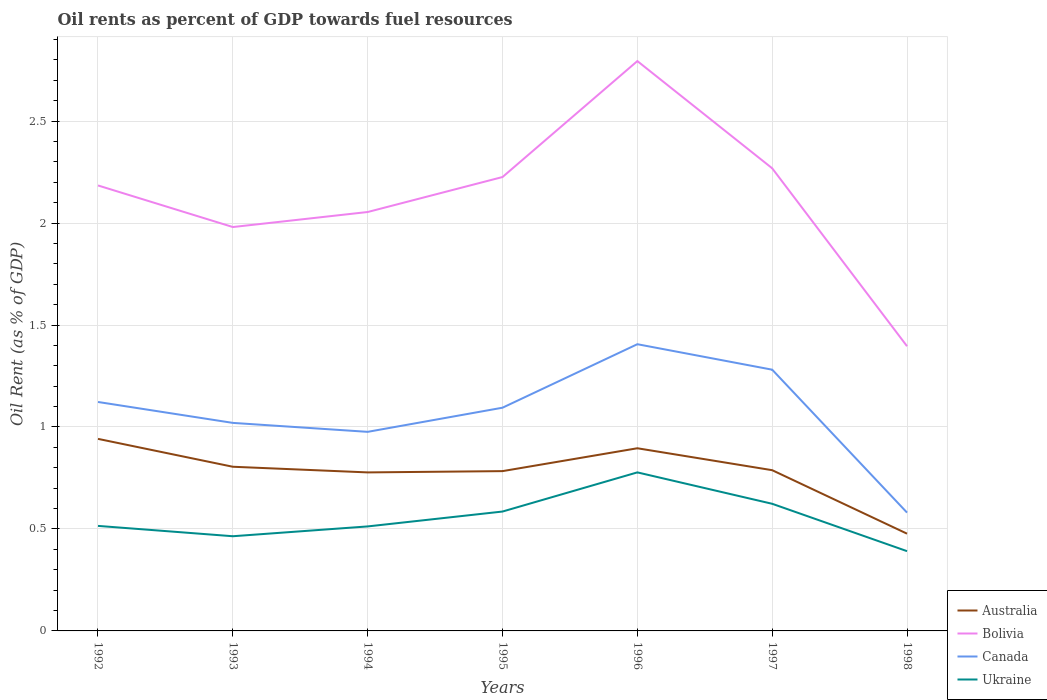Does the line corresponding to Ukraine intersect with the line corresponding to Bolivia?
Provide a succinct answer. No. Across all years, what is the maximum oil rent in Canada?
Offer a very short reply. 0.58. In which year was the oil rent in Australia maximum?
Your response must be concise. 1998. What is the total oil rent in Australia in the graph?
Offer a very short reply. 0.46. What is the difference between the highest and the second highest oil rent in Ukraine?
Give a very brief answer. 0.39. How many lines are there?
Ensure brevity in your answer.  4. What is the difference between two consecutive major ticks on the Y-axis?
Give a very brief answer. 0.5. Does the graph contain grids?
Offer a very short reply. Yes. Where does the legend appear in the graph?
Offer a very short reply. Bottom right. How are the legend labels stacked?
Offer a very short reply. Vertical. What is the title of the graph?
Provide a succinct answer. Oil rents as percent of GDP towards fuel resources. Does "Cayman Islands" appear as one of the legend labels in the graph?
Make the answer very short. No. What is the label or title of the Y-axis?
Ensure brevity in your answer.  Oil Rent (as % of GDP). What is the Oil Rent (as % of GDP) of Australia in 1992?
Provide a short and direct response. 0.94. What is the Oil Rent (as % of GDP) in Bolivia in 1992?
Your answer should be compact. 2.18. What is the Oil Rent (as % of GDP) of Canada in 1992?
Offer a very short reply. 1.12. What is the Oil Rent (as % of GDP) in Ukraine in 1992?
Give a very brief answer. 0.52. What is the Oil Rent (as % of GDP) in Australia in 1993?
Offer a very short reply. 0.81. What is the Oil Rent (as % of GDP) of Bolivia in 1993?
Keep it short and to the point. 1.98. What is the Oil Rent (as % of GDP) of Canada in 1993?
Your answer should be compact. 1.02. What is the Oil Rent (as % of GDP) of Ukraine in 1993?
Offer a very short reply. 0.46. What is the Oil Rent (as % of GDP) of Australia in 1994?
Offer a very short reply. 0.78. What is the Oil Rent (as % of GDP) of Bolivia in 1994?
Your answer should be compact. 2.05. What is the Oil Rent (as % of GDP) of Canada in 1994?
Keep it short and to the point. 0.98. What is the Oil Rent (as % of GDP) in Ukraine in 1994?
Make the answer very short. 0.51. What is the Oil Rent (as % of GDP) of Australia in 1995?
Provide a short and direct response. 0.78. What is the Oil Rent (as % of GDP) of Bolivia in 1995?
Keep it short and to the point. 2.23. What is the Oil Rent (as % of GDP) in Canada in 1995?
Ensure brevity in your answer.  1.09. What is the Oil Rent (as % of GDP) of Ukraine in 1995?
Offer a terse response. 0.59. What is the Oil Rent (as % of GDP) of Australia in 1996?
Give a very brief answer. 0.9. What is the Oil Rent (as % of GDP) in Bolivia in 1996?
Your answer should be very brief. 2.79. What is the Oil Rent (as % of GDP) of Canada in 1996?
Keep it short and to the point. 1.41. What is the Oil Rent (as % of GDP) of Ukraine in 1996?
Your answer should be very brief. 0.78. What is the Oil Rent (as % of GDP) in Australia in 1997?
Your response must be concise. 0.79. What is the Oil Rent (as % of GDP) of Bolivia in 1997?
Offer a terse response. 2.27. What is the Oil Rent (as % of GDP) in Canada in 1997?
Your response must be concise. 1.28. What is the Oil Rent (as % of GDP) of Ukraine in 1997?
Ensure brevity in your answer.  0.62. What is the Oil Rent (as % of GDP) of Australia in 1998?
Give a very brief answer. 0.48. What is the Oil Rent (as % of GDP) in Bolivia in 1998?
Provide a succinct answer. 1.4. What is the Oil Rent (as % of GDP) in Canada in 1998?
Your answer should be very brief. 0.58. What is the Oil Rent (as % of GDP) of Ukraine in 1998?
Make the answer very short. 0.39. Across all years, what is the maximum Oil Rent (as % of GDP) in Australia?
Provide a short and direct response. 0.94. Across all years, what is the maximum Oil Rent (as % of GDP) of Bolivia?
Your answer should be compact. 2.79. Across all years, what is the maximum Oil Rent (as % of GDP) of Canada?
Ensure brevity in your answer.  1.41. Across all years, what is the maximum Oil Rent (as % of GDP) in Ukraine?
Your answer should be compact. 0.78. Across all years, what is the minimum Oil Rent (as % of GDP) of Australia?
Offer a very short reply. 0.48. Across all years, what is the minimum Oil Rent (as % of GDP) in Bolivia?
Ensure brevity in your answer.  1.4. Across all years, what is the minimum Oil Rent (as % of GDP) of Canada?
Give a very brief answer. 0.58. Across all years, what is the minimum Oil Rent (as % of GDP) of Ukraine?
Your answer should be compact. 0.39. What is the total Oil Rent (as % of GDP) in Australia in the graph?
Your response must be concise. 5.47. What is the total Oil Rent (as % of GDP) of Bolivia in the graph?
Provide a succinct answer. 14.9. What is the total Oil Rent (as % of GDP) in Canada in the graph?
Provide a short and direct response. 7.48. What is the total Oil Rent (as % of GDP) in Ukraine in the graph?
Provide a succinct answer. 3.87. What is the difference between the Oil Rent (as % of GDP) in Australia in 1992 and that in 1993?
Offer a very short reply. 0.14. What is the difference between the Oil Rent (as % of GDP) in Bolivia in 1992 and that in 1993?
Your answer should be compact. 0.2. What is the difference between the Oil Rent (as % of GDP) in Canada in 1992 and that in 1993?
Provide a short and direct response. 0.1. What is the difference between the Oil Rent (as % of GDP) in Ukraine in 1992 and that in 1993?
Give a very brief answer. 0.05. What is the difference between the Oil Rent (as % of GDP) in Australia in 1992 and that in 1994?
Provide a short and direct response. 0.16. What is the difference between the Oil Rent (as % of GDP) of Bolivia in 1992 and that in 1994?
Provide a short and direct response. 0.13. What is the difference between the Oil Rent (as % of GDP) in Canada in 1992 and that in 1994?
Provide a succinct answer. 0.15. What is the difference between the Oil Rent (as % of GDP) of Ukraine in 1992 and that in 1994?
Provide a succinct answer. 0. What is the difference between the Oil Rent (as % of GDP) in Australia in 1992 and that in 1995?
Provide a short and direct response. 0.16. What is the difference between the Oil Rent (as % of GDP) in Bolivia in 1992 and that in 1995?
Your response must be concise. -0.04. What is the difference between the Oil Rent (as % of GDP) in Canada in 1992 and that in 1995?
Ensure brevity in your answer.  0.03. What is the difference between the Oil Rent (as % of GDP) of Ukraine in 1992 and that in 1995?
Give a very brief answer. -0.07. What is the difference between the Oil Rent (as % of GDP) in Australia in 1992 and that in 1996?
Keep it short and to the point. 0.05. What is the difference between the Oil Rent (as % of GDP) in Bolivia in 1992 and that in 1996?
Your response must be concise. -0.61. What is the difference between the Oil Rent (as % of GDP) in Canada in 1992 and that in 1996?
Offer a terse response. -0.28. What is the difference between the Oil Rent (as % of GDP) in Ukraine in 1992 and that in 1996?
Ensure brevity in your answer.  -0.26. What is the difference between the Oil Rent (as % of GDP) in Australia in 1992 and that in 1997?
Provide a short and direct response. 0.15. What is the difference between the Oil Rent (as % of GDP) in Bolivia in 1992 and that in 1997?
Give a very brief answer. -0.08. What is the difference between the Oil Rent (as % of GDP) of Canada in 1992 and that in 1997?
Offer a terse response. -0.16. What is the difference between the Oil Rent (as % of GDP) in Ukraine in 1992 and that in 1997?
Keep it short and to the point. -0.11. What is the difference between the Oil Rent (as % of GDP) in Australia in 1992 and that in 1998?
Make the answer very short. 0.46. What is the difference between the Oil Rent (as % of GDP) in Bolivia in 1992 and that in 1998?
Your answer should be compact. 0.79. What is the difference between the Oil Rent (as % of GDP) in Canada in 1992 and that in 1998?
Your response must be concise. 0.54. What is the difference between the Oil Rent (as % of GDP) of Ukraine in 1992 and that in 1998?
Provide a short and direct response. 0.12. What is the difference between the Oil Rent (as % of GDP) of Australia in 1993 and that in 1994?
Keep it short and to the point. 0.03. What is the difference between the Oil Rent (as % of GDP) in Bolivia in 1993 and that in 1994?
Offer a very short reply. -0.07. What is the difference between the Oil Rent (as % of GDP) in Canada in 1993 and that in 1994?
Keep it short and to the point. 0.04. What is the difference between the Oil Rent (as % of GDP) in Ukraine in 1993 and that in 1994?
Your answer should be very brief. -0.05. What is the difference between the Oil Rent (as % of GDP) of Australia in 1993 and that in 1995?
Your answer should be compact. 0.02. What is the difference between the Oil Rent (as % of GDP) of Bolivia in 1993 and that in 1995?
Give a very brief answer. -0.25. What is the difference between the Oil Rent (as % of GDP) in Canada in 1993 and that in 1995?
Ensure brevity in your answer.  -0.07. What is the difference between the Oil Rent (as % of GDP) in Ukraine in 1993 and that in 1995?
Give a very brief answer. -0.12. What is the difference between the Oil Rent (as % of GDP) in Australia in 1993 and that in 1996?
Your answer should be compact. -0.09. What is the difference between the Oil Rent (as % of GDP) in Bolivia in 1993 and that in 1996?
Offer a terse response. -0.81. What is the difference between the Oil Rent (as % of GDP) of Canada in 1993 and that in 1996?
Give a very brief answer. -0.39. What is the difference between the Oil Rent (as % of GDP) of Ukraine in 1993 and that in 1996?
Offer a very short reply. -0.31. What is the difference between the Oil Rent (as % of GDP) of Australia in 1993 and that in 1997?
Your answer should be compact. 0.02. What is the difference between the Oil Rent (as % of GDP) in Bolivia in 1993 and that in 1997?
Provide a short and direct response. -0.29. What is the difference between the Oil Rent (as % of GDP) in Canada in 1993 and that in 1997?
Make the answer very short. -0.26. What is the difference between the Oil Rent (as % of GDP) of Ukraine in 1993 and that in 1997?
Provide a short and direct response. -0.16. What is the difference between the Oil Rent (as % of GDP) of Australia in 1993 and that in 1998?
Your response must be concise. 0.33. What is the difference between the Oil Rent (as % of GDP) of Bolivia in 1993 and that in 1998?
Ensure brevity in your answer.  0.58. What is the difference between the Oil Rent (as % of GDP) of Canada in 1993 and that in 1998?
Provide a short and direct response. 0.44. What is the difference between the Oil Rent (as % of GDP) in Ukraine in 1993 and that in 1998?
Ensure brevity in your answer.  0.07. What is the difference between the Oil Rent (as % of GDP) in Australia in 1994 and that in 1995?
Your answer should be very brief. -0.01. What is the difference between the Oil Rent (as % of GDP) in Bolivia in 1994 and that in 1995?
Ensure brevity in your answer.  -0.17. What is the difference between the Oil Rent (as % of GDP) of Canada in 1994 and that in 1995?
Offer a terse response. -0.12. What is the difference between the Oil Rent (as % of GDP) of Ukraine in 1994 and that in 1995?
Give a very brief answer. -0.07. What is the difference between the Oil Rent (as % of GDP) of Australia in 1994 and that in 1996?
Offer a very short reply. -0.12. What is the difference between the Oil Rent (as % of GDP) of Bolivia in 1994 and that in 1996?
Your response must be concise. -0.74. What is the difference between the Oil Rent (as % of GDP) of Canada in 1994 and that in 1996?
Ensure brevity in your answer.  -0.43. What is the difference between the Oil Rent (as % of GDP) of Ukraine in 1994 and that in 1996?
Your answer should be compact. -0.27. What is the difference between the Oil Rent (as % of GDP) of Australia in 1994 and that in 1997?
Offer a very short reply. -0.01. What is the difference between the Oil Rent (as % of GDP) in Bolivia in 1994 and that in 1997?
Your answer should be compact. -0.21. What is the difference between the Oil Rent (as % of GDP) of Canada in 1994 and that in 1997?
Your response must be concise. -0.3. What is the difference between the Oil Rent (as % of GDP) in Ukraine in 1994 and that in 1997?
Provide a short and direct response. -0.11. What is the difference between the Oil Rent (as % of GDP) of Australia in 1994 and that in 1998?
Give a very brief answer. 0.3. What is the difference between the Oil Rent (as % of GDP) in Bolivia in 1994 and that in 1998?
Your answer should be very brief. 0.66. What is the difference between the Oil Rent (as % of GDP) of Canada in 1994 and that in 1998?
Give a very brief answer. 0.4. What is the difference between the Oil Rent (as % of GDP) in Ukraine in 1994 and that in 1998?
Provide a short and direct response. 0.12. What is the difference between the Oil Rent (as % of GDP) in Australia in 1995 and that in 1996?
Offer a very short reply. -0.11. What is the difference between the Oil Rent (as % of GDP) of Bolivia in 1995 and that in 1996?
Give a very brief answer. -0.57. What is the difference between the Oil Rent (as % of GDP) in Canada in 1995 and that in 1996?
Your answer should be very brief. -0.31. What is the difference between the Oil Rent (as % of GDP) of Ukraine in 1995 and that in 1996?
Offer a very short reply. -0.19. What is the difference between the Oil Rent (as % of GDP) in Australia in 1995 and that in 1997?
Give a very brief answer. -0. What is the difference between the Oil Rent (as % of GDP) of Bolivia in 1995 and that in 1997?
Offer a very short reply. -0.04. What is the difference between the Oil Rent (as % of GDP) of Canada in 1995 and that in 1997?
Keep it short and to the point. -0.19. What is the difference between the Oil Rent (as % of GDP) in Ukraine in 1995 and that in 1997?
Give a very brief answer. -0.04. What is the difference between the Oil Rent (as % of GDP) of Australia in 1995 and that in 1998?
Your answer should be very brief. 0.31. What is the difference between the Oil Rent (as % of GDP) of Bolivia in 1995 and that in 1998?
Offer a terse response. 0.83. What is the difference between the Oil Rent (as % of GDP) in Canada in 1995 and that in 1998?
Ensure brevity in your answer.  0.51. What is the difference between the Oil Rent (as % of GDP) of Ukraine in 1995 and that in 1998?
Offer a very short reply. 0.19. What is the difference between the Oil Rent (as % of GDP) in Australia in 1996 and that in 1997?
Give a very brief answer. 0.11. What is the difference between the Oil Rent (as % of GDP) of Bolivia in 1996 and that in 1997?
Your answer should be compact. 0.53. What is the difference between the Oil Rent (as % of GDP) in Canada in 1996 and that in 1997?
Offer a very short reply. 0.12. What is the difference between the Oil Rent (as % of GDP) of Ukraine in 1996 and that in 1997?
Make the answer very short. 0.15. What is the difference between the Oil Rent (as % of GDP) of Australia in 1996 and that in 1998?
Give a very brief answer. 0.42. What is the difference between the Oil Rent (as % of GDP) in Bolivia in 1996 and that in 1998?
Give a very brief answer. 1.4. What is the difference between the Oil Rent (as % of GDP) in Canada in 1996 and that in 1998?
Ensure brevity in your answer.  0.83. What is the difference between the Oil Rent (as % of GDP) of Ukraine in 1996 and that in 1998?
Offer a terse response. 0.39. What is the difference between the Oil Rent (as % of GDP) in Australia in 1997 and that in 1998?
Your response must be concise. 0.31. What is the difference between the Oil Rent (as % of GDP) of Bolivia in 1997 and that in 1998?
Offer a terse response. 0.87. What is the difference between the Oil Rent (as % of GDP) in Canada in 1997 and that in 1998?
Your response must be concise. 0.7. What is the difference between the Oil Rent (as % of GDP) in Ukraine in 1997 and that in 1998?
Your response must be concise. 0.23. What is the difference between the Oil Rent (as % of GDP) of Australia in 1992 and the Oil Rent (as % of GDP) of Bolivia in 1993?
Ensure brevity in your answer.  -1.04. What is the difference between the Oil Rent (as % of GDP) in Australia in 1992 and the Oil Rent (as % of GDP) in Canada in 1993?
Provide a short and direct response. -0.08. What is the difference between the Oil Rent (as % of GDP) of Australia in 1992 and the Oil Rent (as % of GDP) of Ukraine in 1993?
Offer a terse response. 0.48. What is the difference between the Oil Rent (as % of GDP) in Bolivia in 1992 and the Oil Rent (as % of GDP) in Canada in 1993?
Provide a succinct answer. 1.16. What is the difference between the Oil Rent (as % of GDP) of Bolivia in 1992 and the Oil Rent (as % of GDP) of Ukraine in 1993?
Offer a very short reply. 1.72. What is the difference between the Oil Rent (as % of GDP) of Canada in 1992 and the Oil Rent (as % of GDP) of Ukraine in 1993?
Ensure brevity in your answer.  0.66. What is the difference between the Oil Rent (as % of GDP) in Australia in 1992 and the Oil Rent (as % of GDP) in Bolivia in 1994?
Your answer should be compact. -1.11. What is the difference between the Oil Rent (as % of GDP) in Australia in 1992 and the Oil Rent (as % of GDP) in Canada in 1994?
Give a very brief answer. -0.03. What is the difference between the Oil Rent (as % of GDP) in Australia in 1992 and the Oil Rent (as % of GDP) in Ukraine in 1994?
Make the answer very short. 0.43. What is the difference between the Oil Rent (as % of GDP) in Bolivia in 1992 and the Oil Rent (as % of GDP) in Canada in 1994?
Your answer should be compact. 1.21. What is the difference between the Oil Rent (as % of GDP) in Bolivia in 1992 and the Oil Rent (as % of GDP) in Ukraine in 1994?
Give a very brief answer. 1.67. What is the difference between the Oil Rent (as % of GDP) of Canada in 1992 and the Oil Rent (as % of GDP) of Ukraine in 1994?
Ensure brevity in your answer.  0.61. What is the difference between the Oil Rent (as % of GDP) of Australia in 1992 and the Oil Rent (as % of GDP) of Bolivia in 1995?
Your answer should be compact. -1.28. What is the difference between the Oil Rent (as % of GDP) in Australia in 1992 and the Oil Rent (as % of GDP) in Canada in 1995?
Your answer should be very brief. -0.15. What is the difference between the Oil Rent (as % of GDP) in Australia in 1992 and the Oil Rent (as % of GDP) in Ukraine in 1995?
Make the answer very short. 0.36. What is the difference between the Oil Rent (as % of GDP) in Bolivia in 1992 and the Oil Rent (as % of GDP) in Canada in 1995?
Your response must be concise. 1.09. What is the difference between the Oil Rent (as % of GDP) in Bolivia in 1992 and the Oil Rent (as % of GDP) in Ukraine in 1995?
Keep it short and to the point. 1.6. What is the difference between the Oil Rent (as % of GDP) of Canada in 1992 and the Oil Rent (as % of GDP) of Ukraine in 1995?
Your answer should be very brief. 0.54. What is the difference between the Oil Rent (as % of GDP) of Australia in 1992 and the Oil Rent (as % of GDP) of Bolivia in 1996?
Your answer should be very brief. -1.85. What is the difference between the Oil Rent (as % of GDP) of Australia in 1992 and the Oil Rent (as % of GDP) of Canada in 1996?
Provide a short and direct response. -0.46. What is the difference between the Oil Rent (as % of GDP) in Australia in 1992 and the Oil Rent (as % of GDP) in Ukraine in 1996?
Keep it short and to the point. 0.16. What is the difference between the Oil Rent (as % of GDP) of Bolivia in 1992 and the Oil Rent (as % of GDP) of Canada in 1996?
Your response must be concise. 0.78. What is the difference between the Oil Rent (as % of GDP) of Bolivia in 1992 and the Oil Rent (as % of GDP) of Ukraine in 1996?
Make the answer very short. 1.41. What is the difference between the Oil Rent (as % of GDP) of Canada in 1992 and the Oil Rent (as % of GDP) of Ukraine in 1996?
Make the answer very short. 0.35. What is the difference between the Oil Rent (as % of GDP) in Australia in 1992 and the Oil Rent (as % of GDP) in Bolivia in 1997?
Give a very brief answer. -1.33. What is the difference between the Oil Rent (as % of GDP) of Australia in 1992 and the Oil Rent (as % of GDP) of Canada in 1997?
Your answer should be very brief. -0.34. What is the difference between the Oil Rent (as % of GDP) of Australia in 1992 and the Oil Rent (as % of GDP) of Ukraine in 1997?
Keep it short and to the point. 0.32. What is the difference between the Oil Rent (as % of GDP) in Bolivia in 1992 and the Oil Rent (as % of GDP) in Canada in 1997?
Your response must be concise. 0.9. What is the difference between the Oil Rent (as % of GDP) in Bolivia in 1992 and the Oil Rent (as % of GDP) in Ukraine in 1997?
Ensure brevity in your answer.  1.56. What is the difference between the Oil Rent (as % of GDP) in Canada in 1992 and the Oil Rent (as % of GDP) in Ukraine in 1997?
Provide a succinct answer. 0.5. What is the difference between the Oil Rent (as % of GDP) in Australia in 1992 and the Oil Rent (as % of GDP) in Bolivia in 1998?
Your answer should be very brief. -0.45. What is the difference between the Oil Rent (as % of GDP) in Australia in 1992 and the Oil Rent (as % of GDP) in Canada in 1998?
Give a very brief answer. 0.36. What is the difference between the Oil Rent (as % of GDP) of Australia in 1992 and the Oil Rent (as % of GDP) of Ukraine in 1998?
Offer a terse response. 0.55. What is the difference between the Oil Rent (as % of GDP) of Bolivia in 1992 and the Oil Rent (as % of GDP) of Canada in 1998?
Provide a succinct answer. 1.6. What is the difference between the Oil Rent (as % of GDP) of Bolivia in 1992 and the Oil Rent (as % of GDP) of Ukraine in 1998?
Your response must be concise. 1.79. What is the difference between the Oil Rent (as % of GDP) in Canada in 1992 and the Oil Rent (as % of GDP) in Ukraine in 1998?
Your answer should be very brief. 0.73. What is the difference between the Oil Rent (as % of GDP) of Australia in 1993 and the Oil Rent (as % of GDP) of Bolivia in 1994?
Keep it short and to the point. -1.25. What is the difference between the Oil Rent (as % of GDP) in Australia in 1993 and the Oil Rent (as % of GDP) in Canada in 1994?
Provide a succinct answer. -0.17. What is the difference between the Oil Rent (as % of GDP) in Australia in 1993 and the Oil Rent (as % of GDP) in Ukraine in 1994?
Your answer should be very brief. 0.29. What is the difference between the Oil Rent (as % of GDP) in Bolivia in 1993 and the Oil Rent (as % of GDP) in Ukraine in 1994?
Your answer should be very brief. 1.47. What is the difference between the Oil Rent (as % of GDP) in Canada in 1993 and the Oil Rent (as % of GDP) in Ukraine in 1994?
Your answer should be compact. 0.51. What is the difference between the Oil Rent (as % of GDP) in Australia in 1993 and the Oil Rent (as % of GDP) in Bolivia in 1995?
Ensure brevity in your answer.  -1.42. What is the difference between the Oil Rent (as % of GDP) in Australia in 1993 and the Oil Rent (as % of GDP) in Canada in 1995?
Offer a very short reply. -0.29. What is the difference between the Oil Rent (as % of GDP) in Australia in 1993 and the Oil Rent (as % of GDP) in Ukraine in 1995?
Make the answer very short. 0.22. What is the difference between the Oil Rent (as % of GDP) in Bolivia in 1993 and the Oil Rent (as % of GDP) in Canada in 1995?
Your response must be concise. 0.89. What is the difference between the Oil Rent (as % of GDP) of Bolivia in 1993 and the Oil Rent (as % of GDP) of Ukraine in 1995?
Ensure brevity in your answer.  1.4. What is the difference between the Oil Rent (as % of GDP) of Canada in 1993 and the Oil Rent (as % of GDP) of Ukraine in 1995?
Offer a very short reply. 0.43. What is the difference between the Oil Rent (as % of GDP) of Australia in 1993 and the Oil Rent (as % of GDP) of Bolivia in 1996?
Keep it short and to the point. -1.99. What is the difference between the Oil Rent (as % of GDP) in Australia in 1993 and the Oil Rent (as % of GDP) in Canada in 1996?
Provide a short and direct response. -0.6. What is the difference between the Oil Rent (as % of GDP) of Australia in 1993 and the Oil Rent (as % of GDP) of Ukraine in 1996?
Offer a very short reply. 0.03. What is the difference between the Oil Rent (as % of GDP) of Bolivia in 1993 and the Oil Rent (as % of GDP) of Canada in 1996?
Provide a succinct answer. 0.57. What is the difference between the Oil Rent (as % of GDP) of Bolivia in 1993 and the Oil Rent (as % of GDP) of Ukraine in 1996?
Give a very brief answer. 1.2. What is the difference between the Oil Rent (as % of GDP) of Canada in 1993 and the Oil Rent (as % of GDP) of Ukraine in 1996?
Your response must be concise. 0.24. What is the difference between the Oil Rent (as % of GDP) in Australia in 1993 and the Oil Rent (as % of GDP) in Bolivia in 1997?
Give a very brief answer. -1.46. What is the difference between the Oil Rent (as % of GDP) in Australia in 1993 and the Oil Rent (as % of GDP) in Canada in 1997?
Make the answer very short. -0.48. What is the difference between the Oil Rent (as % of GDP) of Australia in 1993 and the Oil Rent (as % of GDP) of Ukraine in 1997?
Your answer should be very brief. 0.18. What is the difference between the Oil Rent (as % of GDP) of Bolivia in 1993 and the Oil Rent (as % of GDP) of Canada in 1997?
Keep it short and to the point. 0.7. What is the difference between the Oil Rent (as % of GDP) in Bolivia in 1993 and the Oil Rent (as % of GDP) in Ukraine in 1997?
Provide a succinct answer. 1.36. What is the difference between the Oil Rent (as % of GDP) of Canada in 1993 and the Oil Rent (as % of GDP) of Ukraine in 1997?
Your response must be concise. 0.4. What is the difference between the Oil Rent (as % of GDP) of Australia in 1993 and the Oil Rent (as % of GDP) of Bolivia in 1998?
Offer a very short reply. -0.59. What is the difference between the Oil Rent (as % of GDP) of Australia in 1993 and the Oil Rent (as % of GDP) of Canada in 1998?
Ensure brevity in your answer.  0.22. What is the difference between the Oil Rent (as % of GDP) in Australia in 1993 and the Oil Rent (as % of GDP) in Ukraine in 1998?
Your response must be concise. 0.41. What is the difference between the Oil Rent (as % of GDP) of Bolivia in 1993 and the Oil Rent (as % of GDP) of Canada in 1998?
Provide a short and direct response. 1.4. What is the difference between the Oil Rent (as % of GDP) in Bolivia in 1993 and the Oil Rent (as % of GDP) in Ukraine in 1998?
Offer a terse response. 1.59. What is the difference between the Oil Rent (as % of GDP) of Canada in 1993 and the Oil Rent (as % of GDP) of Ukraine in 1998?
Your response must be concise. 0.63. What is the difference between the Oil Rent (as % of GDP) of Australia in 1994 and the Oil Rent (as % of GDP) of Bolivia in 1995?
Ensure brevity in your answer.  -1.45. What is the difference between the Oil Rent (as % of GDP) of Australia in 1994 and the Oil Rent (as % of GDP) of Canada in 1995?
Your response must be concise. -0.32. What is the difference between the Oil Rent (as % of GDP) in Australia in 1994 and the Oil Rent (as % of GDP) in Ukraine in 1995?
Keep it short and to the point. 0.19. What is the difference between the Oil Rent (as % of GDP) of Bolivia in 1994 and the Oil Rent (as % of GDP) of Canada in 1995?
Ensure brevity in your answer.  0.96. What is the difference between the Oil Rent (as % of GDP) in Bolivia in 1994 and the Oil Rent (as % of GDP) in Ukraine in 1995?
Your response must be concise. 1.47. What is the difference between the Oil Rent (as % of GDP) of Canada in 1994 and the Oil Rent (as % of GDP) of Ukraine in 1995?
Your response must be concise. 0.39. What is the difference between the Oil Rent (as % of GDP) of Australia in 1994 and the Oil Rent (as % of GDP) of Bolivia in 1996?
Ensure brevity in your answer.  -2.02. What is the difference between the Oil Rent (as % of GDP) of Australia in 1994 and the Oil Rent (as % of GDP) of Canada in 1996?
Your answer should be compact. -0.63. What is the difference between the Oil Rent (as % of GDP) of Australia in 1994 and the Oil Rent (as % of GDP) of Ukraine in 1996?
Keep it short and to the point. -0. What is the difference between the Oil Rent (as % of GDP) in Bolivia in 1994 and the Oil Rent (as % of GDP) in Canada in 1996?
Offer a very short reply. 0.65. What is the difference between the Oil Rent (as % of GDP) in Bolivia in 1994 and the Oil Rent (as % of GDP) in Ukraine in 1996?
Make the answer very short. 1.28. What is the difference between the Oil Rent (as % of GDP) in Canada in 1994 and the Oil Rent (as % of GDP) in Ukraine in 1996?
Make the answer very short. 0.2. What is the difference between the Oil Rent (as % of GDP) of Australia in 1994 and the Oil Rent (as % of GDP) of Bolivia in 1997?
Give a very brief answer. -1.49. What is the difference between the Oil Rent (as % of GDP) in Australia in 1994 and the Oil Rent (as % of GDP) in Canada in 1997?
Provide a succinct answer. -0.5. What is the difference between the Oil Rent (as % of GDP) of Australia in 1994 and the Oil Rent (as % of GDP) of Ukraine in 1997?
Provide a short and direct response. 0.15. What is the difference between the Oil Rent (as % of GDP) of Bolivia in 1994 and the Oil Rent (as % of GDP) of Canada in 1997?
Ensure brevity in your answer.  0.77. What is the difference between the Oil Rent (as % of GDP) in Bolivia in 1994 and the Oil Rent (as % of GDP) in Ukraine in 1997?
Keep it short and to the point. 1.43. What is the difference between the Oil Rent (as % of GDP) of Canada in 1994 and the Oil Rent (as % of GDP) of Ukraine in 1997?
Make the answer very short. 0.35. What is the difference between the Oil Rent (as % of GDP) in Australia in 1994 and the Oil Rent (as % of GDP) in Bolivia in 1998?
Provide a short and direct response. -0.62. What is the difference between the Oil Rent (as % of GDP) of Australia in 1994 and the Oil Rent (as % of GDP) of Canada in 1998?
Your answer should be very brief. 0.2. What is the difference between the Oil Rent (as % of GDP) in Australia in 1994 and the Oil Rent (as % of GDP) in Ukraine in 1998?
Offer a terse response. 0.39. What is the difference between the Oil Rent (as % of GDP) in Bolivia in 1994 and the Oil Rent (as % of GDP) in Canada in 1998?
Keep it short and to the point. 1.47. What is the difference between the Oil Rent (as % of GDP) of Bolivia in 1994 and the Oil Rent (as % of GDP) of Ukraine in 1998?
Make the answer very short. 1.66. What is the difference between the Oil Rent (as % of GDP) in Canada in 1994 and the Oil Rent (as % of GDP) in Ukraine in 1998?
Your answer should be compact. 0.59. What is the difference between the Oil Rent (as % of GDP) of Australia in 1995 and the Oil Rent (as % of GDP) of Bolivia in 1996?
Make the answer very short. -2.01. What is the difference between the Oil Rent (as % of GDP) in Australia in 1995 and the Oil Rent (as % of GDP) in Canada in 1996?
Your answer should be compact. -0.62. What is the difference between the Oil Rent (as % of GDP) of Australia in 1995 and the Oil Rent (as % of GDP) of Ukraine in 1996?
Your answer should be very brief. 0.01. What is the difference between the Oil Rent (as % of GDP) of Bolivia in 1995 and the Oil Rent (as % of GDP) of Canada in 1996?
Your answer should be very brief. 0.82. What is the difference between the Oil Rent (as % of GDP) of Bolivia in 1995 and the Oil Rent (as % of GDP) of Ukraine in 1996?
Make the answer very short. 1.45. What is the difference between the Oil Rent (as % of GDP) of Canada in 1995 and the Oil Rent (as % of GDP) of Ukraine in 1996?
Offer a terse response. 0.32. What is the difference between the Oil Rent (as % of GDP) of Australia in 1995 and the Oil Rent (as % of GDP) of Bolivia in 1997?
Provide a succinct answer. -1.49. What is the difference between the Oil Rent (as % of GDP) of Australia in 1995 and the Oil Rent (as % of GDP) of Canada in 1997?
Your response must be concise. -0.5. What is the difference between the Oil Rent (as % of GDP) in Australia in 1995 and the Oil Rent (as % of GDP) in Ukraine in 1997?
Ensure brevity in your answer.  0.16. What is the difference between the Oil Rent (as % of GDP) in Bolivia in 1995 and the Oil Rent (as % of GDP) in Canada in 1997?
Ensure brevity in your answer.  0.94. What is the difference between the Oil Rent (as % of GDP) in Bolivia in 1995 and the Oil Rent (as % of GDP) in Ukraine in 1997?
Offer a very short reply. 1.6. What is the difference between the Oil Rent (as % of GDP) in Canada in 1995 and the Oil Rent (as % of GDP) in Ukraine in 1997?
Your answer should be very brief. 0.47. What is the difference between the Oil Rent (as % of GDP) in Australia in 1995 and the Oil Rent (as % of GDP) in Bolivia in 1998?
Your response must be concise. -0.61. What is the difference between the Oil Rent (as % of GDP) of Australia in 1995 and the Oil Rent (as % of GDP) of Canada in 1998?
Provide a succinct answer. 0.2. What is the difference between the Oil Rent (as % of GDP) of Australia in 1995 and the Oil Rent (as % of GDP) of Ukraine in 1998?
Provide a short and direct response. 0.39. What is the difference between the Oil Rent (as % of GDP) of Bolivia in 1995 and the Oil Rent (as % of GDP) of Canada in 1998?
Keep it short and to the point. 1.65. What is the difference between the Oil Rent (as % of GDP) of Bolivia in 1995 and the Oil Rent (as % of GDP) of Ukraine in 1998?
Provide a succinct answer. 1.83. What is the difference between the Oil Rent (as % of GDP) in Canada in 1995 and the Oil Rent (as % of GDP) in Ukraine in 1998?
Keep it short and to the point. 0.7. What is the difference between the Oil Rent (as % of GDP) in Australia in 1996 and the Oil Rent (as % of GDP) in Bolivia in 1997?
Provide a short and direct response. -1.37. What is the difference between the Oil Rent (as % of GDP) of Australia in 1996 and the Oil Rent (as % of GDP) of Canada in 1997?
Your answer should be very brief. -0.39. What is the difference between the Oil Rent (as % of GDP) in Australia in 1996 and the Oil Rent (as % of GDP) in Ukraine in 1997?
Offer a terse response. 0.27. What is the difference between the Oil Rent (as % of GDP) of Bolivia in 1996 and the Oil Rent (as % of GDP) of Canada in 1997?
Provide a short and direct response. 1.51. What is the difference between the Oil Rent (as % of GDP) of Bolivia in 1996 and the Oil Rent (as % of GDP) of Ukraine in 1997?
Give a very brief answer. 2.17. What is the difference between the Oil Rent (as % of GDP) in Canada in 1996 and the Oil Rent (as % of GDP) in Ukraine in 1997?
Offer a very short reply. 0.78. What is the difference between the Oil Rent (as % of GDP) in Australia in 1996 and the Oil Rent (as % of GDP) in Bolivia in 1998?
Your answer should be very brief. -0.5. What is the difference between the Oil Rent (as % of GDP) of Australia in 1996 and the Oil Rent (as % of GDP) of Canada in 1998?
Offer a terse response. 0.32. What is the difference between the Oil Rent (as % of GDP) of Australia in 1996 and the Oil Rent (as % of GDP) of Ukraine in 1998?
Make the answer very short. 0.5. What is the difference between the Oil Rent (as % of GDP) of Bolivia in 1996 and the Oil Rent (as % of GDP) of Canada in 1998?
Your response must be concise. 2.21. What is the difference between the Oil Rent (as % of GDP) in Bolivia in 1996 and the Oil Rent (as % of GDP) in Ukraine in 1998?
Ensure brevity in your answer.  2.4. What is the difference between the Oil Rent (as % of GDP) in Canada in 1996 and the Oil Rent (as % of GDP) in Ukraine in 1998?
Offer a terse response. 1.01. What is the difference between the Oil Rent (as % of GDP) in Australia in 1997 and the Oil Rent (as % of GDP) in Bolivia in 1998?
Provide a succinct answer. -0.61. What is the difference between the Oil Rent (as % of GDP) in Australia in 1997 and the Oil Rent (as % of GDP) in Canada in 1998?
Provide a short and direct response. 0.21. What is the difference between the Oil Rent (as % of GDP) in Australia in 1997 and the Oil Rent (as % of GDP) in Ukraine in 1998?
Give a very brief answer. 0.4. What is the difference between the Oil Rent (as % of GDP) in Bolivia in 1997 and the Oil Rent (as % of GDP) in Canada in 1998?
Your answer should be very brief. 1.69. What is the difference between the Oil Rent (as % of GDP) of Bolivia in 1997 and the Oil Rent (as % of GDP) of Ukraine in 1998?
Keep it short and to the point. 1.88. What is the difference between the Oil Rent (as % of GDP) in Canada in 1997 and the Oil Rent (as % of GDP) in Ukraine in 1998?
Your answer should be compact. 0.89. What is the average Oil Rent (as % of GDP) in Australia per year?
Your answer should be very brief. 0.78. What is the average Oil Rent (as % of GDP) of Bolivia per year?
Offer a terse response. 2.13. What is the average Oil Rent (as % of GDP) in Canada per year?
Make the answer very short. 1.07. What is the average Oil Rent (as % of GDP) of Ukraine per year?
Your answer should be compact. 0.55. In the year 1992, what is the difference between the Oil Rent (as % of GDP) in Australia and Oil Rent (as % of GDP) in Bolivia?
Offer a very short reply. -1.24. In the year 1992, what is the difference between the Oil Rent (as % of GDP) of Australia and Oil Rent (as % of GDP) of Canada?
Provide a succinct answer. -0.18. In the year 1992, what is the difference between the Oil Rent (as % of GDP) in Australia and Oil Rent (as % of GDP) in Ukraine?
Provide a succinct answer. 0.43. In the year 1992, what is the difference between the Oil Rent (as % of GDP) in Bolivia and Oil Rent (as % of GDP) in Canada?
Give a very brief answer. 1.06. In the year 1992, what is the difference between the Oil Rent (as % of GDP) in Bolivia and Oil Rent (as % of GDP) in Ukraine?
Your answer should be compact. 1.67. In the year 1992, what is the difference between the Oil Rent (as % of GDP) of Canada and Oil Rent (as % of GDP) of Ukraine?
Ensure brevity in your answer.  0.61. In the year 1993, what is the difference between the Oil Rent (as % of GDP) of Australia and Oil Rent (as % of GDP) of Bolivia?
Make the answer very short. -1.18. In the year 1993, what is the difference between the Oil Rent (as % of GDP) of Australia and Oil Rent (as % of GDP) of Canada?
Offer a very short reply. -0.22. In the year 1993, what is the difference between the Oil Rent (as % of GDP) in Australia and Oil Rent (as % of GDP) in Ukraine?
Offer a very short reply. 0.34. In the year 1993, what is the difference between the Oil Rent (as % of GDP) of Bolivia and Oil Rent (as % of GDP) of Canada?
Offer a terse response. 0.96. In the year 1993, what is the difference between the Oil Rent (as % of GDP) in Bolivia and Oil Rent (as % of GDP) in Ukraine?
Provide a succinct answer. 1.52. In the year 1993, what is the difference between the Oil Rent (as % of GDP) of Canada and Oil Rent (as % of GDP) of Ukraine?
Your response must be concise. 0.56. In the year 1994, what is the difference between the Oil Rent (as % of GDP) in Australia and Oil Rent (as % of GDP) in Bolivia?
Make the answer very short. -1.28. In the year 1994, what is the difference between the Oil Rent (as % of GDP) in Australia and Oil Rent (as % of GDP) in Canada?
Your response must be concise. -0.2. In the year 1994, what is the difference between the Oil Rent (as % of GDP) in Australia and Oil Rent (as % of GDP) in Ukraine?
Give a very brief answer. 0.26. In the year 1994, what is the difference between the Oil Rent (as % of GDP) in Bolivia and Oil Rent (as % of GDP) in Canada?
Give a very brief answer. 1.08. In the year 1994, what is the difference between the Oil Rent (as % of GDP) in Bolivia and Oil Rent (as % of GDP) in Ukraine?
Provide a succinct answer. 1.54. In the year 1994, what is the difference between the Oil Rent (as % of GDP) in Canada and Oil Rent (as % of GDP) in Ukraine?
Offer a very short reply. 0.46. In the year 1995, what is the difference between the Oil Rent (as % of GDP) in Australia and Oil Rent (as % of GDP) in Bolivia?
Ensure brevity in your answer.  -1.44. In the year 1995, what is the difference between the Oil Rent (as % of GDP) in Australia and Oil Rent (as % of GDP) in Canada?
Your answer should be compact. -0.31. In the year 1995, what is the difference between the Oil Rent (as % of GDP) in Australia and Oil Rent (as % of GDP) in Ukraine?
Your response must be concise. 0.2. In the year 1995, what is the difference between the Oil Rent (as % of GDP) in Bolivia and Oil Rent (as % of GDP) in Canada?
Offer a very short reply. 1.13. In the year 1995, what is the difference between the Oil Rent (as % of GDP) in Bolivia and Oil Rent (as % of GDP) in Ukraine?
Give a very brief answer. 1.64. In the year 1995, what is the difference between the Oil Rent (as % of GDP) of Canada and Oil Rent (as % of GDP) of Ukraine?
Offer a terse response. 0.51. In the year 1996, what is the difference between the Oil Rent (as % of GDP) of Australia and Oil Rent (as % of GDP) of Bolivia?
Provide a succinct answer. -1.9. In the year 1996, what is the difference between the Oil Rent (as % of GDP) of Australia and Oil Rent (as % of GDP) of Canada?
Offer a terse response. -0.51. In the year 1996, what is the difference between the Oil Rent (as % of GDP) of Australia and Oil Rent (as % of GDP) of Ukraine?
Keep it short and to the point. 0.12. In the year 1996, what is the difference between the Oil Rent (as % of GDP) of Bolivia and Oil Rent (as % of GDP) of Canada?
Provide a short and direct response. 1.39. In the year 1996, what is the difference between the Oil Rent (as % of GDP) of Bolivia and Oil Rent (as % of GDP) of Ukraine?
Offer a terse response. 2.02. In the year 1996, what is the difference between the Oil Rent (as % of GDP) in Canada and Oil Rent (as % of GDP) in Ukraine?
Your answer should be compact. 0.63. In the year 1997, what is the difference between the Oil Rent (as % of GDP) in Australia and Oil Rent (as % of GDP) in Bolivia?
Your response must be concise. -1.48. In the year 1997, what is the difference between the Oil Rent (as % of GDP) in Australia and Oil Rent (as % of GDP) in Canada?
Your answer should be very brief. -0.49. In the year 1997, what is the difference between the Oil Rent (as % of GDP) in Australia and Oil Rent (as % of GDP) in Ukraine?
Provide a short and direct response. 0.16. In the year 1997, what is the difference between the Oil Rent (as % of GDP) of Bolivia and Oil Rent (as % of GDP) of Canada?
Your answer should be compact. 0.99. In the year 1997, what is the difference between the Oil Rent (as % of GDP) of Bolivia and Oil Rent (as % of GDP) of Ukraine?
Make the answer very short. 1.65. In the year 1997, what is the difference between the Oil Rent (as % of GDP) in Canada and Oil Rent (as % of GDP) in Ukraine?
Give a very brief answer. 0.66. In the year 1998, what is the difference between the Oil Rent (as % of GDP) in Australia and Oil Rent (as % of GDP) in Bolivia?
Keep it short and to the point. -0.92. In the year 1998, what is the difference between the Oil Rent (as % of GDP) in Australia and Oil Rent (as % of GDP) in Canada?
Provide a short and direct response. -0.1. In the year 1998, what is the difference between the Oil Rent (as % of GDP) in Australia and Oil Rent (as % of GDP) in Ukraine?
Give a very brief answer. 0.09. In the year 1998, what is the difference between the Oil Rent (as % of GDP) of Bolivia and Oil Rent (as % of GDP) of Canada?
Ensure brevity in your answer.  0.82. In the year 1998, what is the difference between the Oil Rent (as % of GDP) in Canada and Oil Rent (as % of GDP) in Ukraine?
Your response must be concise. 0.19. What is the ratio of the Oil Rent (as % of GDP) of Australia in 1992 to that in 1993?
Offer a terse response. 1.17. What is the ratio of the Oil Rent (as % of GDP) in Bolivia in 1992 to that in 1993?
Provide a short and direct response. 1.1. What is the ratio of the Oil Rent (as % of GDP) in Canada in 1992 to that in 1993?
Offer a terse response. 1.1. What is the ratio of the Oil Rent (as % of GDP) in Ukraine in 1992 to that in 1993?
Offer a terse response. 1.11. What is the ratio of the Oil Rent (as % of GDP) of Australia in 1992 to that in 1994?
Give a very brief answer. 1.21. What is the ratio of the Oil Rent (as % of GDP) of Bolivia in 1992 to that in 1994?
Provide a short and direct response. 1.06. What is the ratio of the Oil Rent (as % of GDP) of Canada in 1992 to that in 1994?
Your answer should be very brief. 1.15. What is the ratio of the Oil Rent (as % of GDP) of Australia in 1992 to that in 1995?
Provide a short and direct response. 1.2. What is the ratio of the Oil Rent (as % of GDP) of Bolivia in 1992 to that in 1995?
Your answer should be very brief. 0.98. What is the ratio of the Oil Rent (as % of GDP) in Canada in 1992 to that in 1995?
Offer a terse response. 1.03. What is the ratio of the Oil Rent (as % of GDP) in Ukraine in 1992 to that in 1995?
Give a very brief answer. 0.88. What is the ratio of the Oil Rent (as % of GDP) of Australia in 1992 to that in 1996?
Your answer should be compact. 1.05. What is the ratio of the Oil Rent (as % of GDP) in Bolivia in 1992 to that in 1996?
Your response must be concise. 0.78. What is the ratio of the Oil Rent (as % of GDP) of Canada in 1992 to that in 1996?
Ensure brevity in your answer.  0.8. What is the ratio of the Oil Rent (as % of GDP) of Ukraine in 1992 to that in 1996?
Your answer should be compact. 0.66. What is the ratio of the Oil Rent (as % of GDP) in Australia in 1992 to that in 1997?
Give a very brief answer. 1.19. What is the ratio of the Oil Rent (as % of GDP) in Bolivia in 1992 to that in 1997?
Offer a terse response. 0.96. What is the ratio of the Oil Rent (as % of GDP) in Canada in 1992 to that in 1997?
Provide a short and direct response. 0.88. What is the ratio of the Oil Rent (as % of GDP) of Ukraine in 1992 to that in 1997?
Give a very brief answer. 0.83. What is the ratio of the Oil Rent (as % of GDP) of Australia in 1992 to that in 1998?
Ensure brevity in your answer.  1.97. What is the ratio of the Oil Rent (as % of GDP) of Bolivia in 1992 to that in 1998?
Your response must be concise. 1.56. What is the ratio of the Oil Rent (as % of GDP) of Canada in 1992 to that in 1998?
Make the answer very short. 1.94. What is the ratio of the Oil Rent (as % of GDP) of Ukraine in 1992 to that in 1998?
Ensure brevity in your answer.  1.32. What is the ratio of the Oil Rent (as % of GDP) in Australia in 1993 to that in 1994?
Provide a short and direct response. 1.04. What is the ratio of the Oil Rent (as % of GDP) of Bolivia in 1993 to that in 1994?
Offer a terse response. 0.96. What is the ratio of the Oil Rent (as % of GDP) in Canada in 1993 to that in 1994?
Give a very brief answer. 1.04. What is the ratio of the Oil Rent (as % of GDP) in Ukraine in 1993 to that in 1994?
Offer a very short reply. 0.91. What is the ratio of the Oil Rent (as % of GDP) of Australia in 1993 to that in 1995?
Your answer should be compact. 1.03. What is the ratio of the Oil Rent (as % of GDP) of Bolivia in 1993 to that in 1995?
Make the answer very short. 0.89. What is the ratio of the Oil Rent (as % of GDP) in Canada in 1993 to that in 1995?
Your response must be concise. 0.93. What is the ratio of the Oil Rent (as % of GDP) in Ukraine in 1993 to that in 1995?
Offer a very short reply. 0.79. What is the ratio of the Oil Rent (as % of GDP) of Australia in 1993 to that in 1996?
Offer a very short reply. 0.9. What is the ratio of the Oil Rent (as % of GDP) of Bolivia in 1993 to that in 1996?
Give a very brief answer. 0.71. What is the ratio of the Oil Rent (as % of GDP) in Canada in 1993 to that in 1996?
Keep it short and to the point. 0.73. What is the ratio of the Oil Rent (as % of GDP) of Ukraine in 1993 to that in 1996?
Your answer should be compact. 0.6. What is the ratio of the Oil Rent (as % of GDP) of Australia in 1993 to that in 1997?
Your answer should be very brief. 1.02. What is the ratio of the Oil Rent (as % of GDP) in Bolivia in 1993 to that in 1997?
Offer a very short reply. 0.87. What is the ratio of the Oil Rent (as % of GDP) in Canada in 1993 to that in 1997?
Your response must be concise. 0.8. What is the ratio of the Oil Rent (as % of GDP) of Ukraine in 1993 to that in 1997?
Provide a succinct answer. 0.74. What is the ratio of the Oil Rent (as % of GDP) of Australia in 1993 to that in 1998?
Ensure brevity in your answer.  1.69. What is the ratio of the Oil Rent (as % of GDP) of Bolivia in 1993 to that in 1998?
Your response must be concise. 1.42. What is the ratio of the Oil Rent (as % of GDP) in Canada in 1993 to that in 1998?
Your answer should be compact. 1.76. What is the ratio of the Oil Rent (as % of GDP) of Ukraine in 1993 to that in 1998?
Keep it short and to the point. 1.19. What is the ratio of the Oil Rent (as % of GDP) in Bolivia in 1994 to that in 1995?
Make the answer very short. 0.92. What is the ratio of the Oil Rent (as % of GDP) of Canada in 1994 to that in 1995?
Offer a very short reply. 0.89. What is the ratio of the Oil Rent (as % of GDP) in Ukraine in 1994 to that in 1995?
Give a very brief answer. 0.88. What is the ratio of the Oil Rent (as % of GDP) of Australia in 1994 to that in 1996?
Your answer should be compact. 0.87. What is the ratio of the Oil Rent (as % of GDP) in Bolivia in 1994 to that in 1996?
Offer a terse response. 0.74. What is the ratio of the Oil Rent (as % of GDP) in Canada in 1994 to that in 1996?
Your answer should be very brief. 0.69. What is the ratio of the Oil Rent (as % of GDP) of Ukraine in 1994 to that in 1996?
Offer a very short reply. 0.66. What is the ratio of the Oil Rent (as % of GDP) of Australia in 1994 to that in 1997?
Provide a succinct answer. 0.99. What is the ratio of the Oil Rent (as % of GDP) in Bolivia in 1994 to that in 1997?
Give a very brief answer. 0.91. What is the ratio of the Oil Rent (as % of GDP) of Canada in 1994 to that in 1997?
Your answer should be very brief. 0.76. What is the ratio of the Oil Rent (as % of GDP) of Ukraine in 1994 to that in 1997?
Ensure brevity in your answer.  0.82. What is the ratio of the Oil Rent (as % of GDP) of Australia in 1994 to that in 1998?
Ensure brevity in your answer.  1.63. What is the ratio of the Oil Rent (as % of GDP) of Bolivia in 1994 to that in 1998?
Give a very brief answer. 1.47. What is the ratio of the Oil Rent (as % of GDP) in Canada in 1994 to that in 1998?
Your response must be concise. 1.68. What is the ratio of the Oil Rent (as % of GDP) of Ukraine in 1994 to that in 1998?
Provide a succinct answer. 1.31. What is the ratio of the Oil Rent (as % of GDP) in Australia in 1995 to that in 1996?
Offer a terse response. 0.87. What is the ratio of the Oil Rent (as % of GDP) in Bolivia in 1995 to that in 1996?
Provide a short and direct response. 0.8. What is the ratio of the Oil Rent (as % of GDP) in Canada in 1995 to that in 1996?
Offer a terse response. 0.78. What is the ratio of the Oil Rent (as % of GDP) in Ukraine in 1995 to that in 1996?
Make the answer very short. 0.75. What is the ratio of the Oil Rent (as % of GDP) of Australia in 1995 to that in 1997?
Your answer should be compact. 0.99. What is the ratio of the Oil Rent (as % of GDP) in Bolivia in 1995 to that in 1997?
Offer a very short reply. 0.98. What is the ratio of the Oil Rent (as % of GDP) in Canada in 1995 to that in 1997?
Give a very brief answer. 0.85. What is the ratio of the Oil Rent (as % of GDP) of Ukraine in 1995 to that in 1997?
Give a very brief answer. 0.94. What is the ratio of the Oil Rent (as % of GDP) in Australia in 1995 to that in 1998?
Ensure brevity in your answer.  1.64. What is the ratio of the Oil Rent (as % of GDP) in Bolivia in 1995 to that in 1998?
Offer a very short reply. 1.59. What is the ratio of the Oil Rent (as % of GDP) in Canada in 1995 to that in 1998?
Provide a short and direct response. 1.89. What is the ratio of the Oil Rent (as % of GDP) of Ukraine in 1995 to that in 1998?
Offer a terse response. 1.5. What is the ratio of the Oil Rent (as % of GDP) in Australia in 1996 to that in 1997?
Your answer should be very brief. 1.14. What is the ratio of the Oil Rent (as % of GDP) of Bolivia in 1996 to that in 1997?
Keep it short and to the point. 1.23. What is the ratio of the Oil Rent (as % of GDP) in Canada in 1996 to that in 1997?
Offer a very short reply. 1.1. What is the ratio of the Oil Rent (as % of GDP) of Ukraine in 1996 to that in 1997?
Your response must be concise. 1.25. What is the ratio of the Oil Rent (as % of GDP) of Australia in 1996 to that in 1998?
Your answer should be compact. 1.88. What is the ratio of the Oil Rent (as % of GDP) in Bolivia in 1996 to that in 1998?
Your response must be concise. 2. What is the ratio of the Oil Rent (as % of GDP) of Canada in 1996 to that in 1998?
Your answer should be compact. 2.42. What is the ratio of the Oil Rent (as % of GDP) of Ukraine in 1996 to that in 1998?
Provide a succinct answer. 1.99. What is the ratio of the Oil Rent (as % of GDP) in Australia in 1997 to that in 1998?
Ensure brevity in your answer.  1.65. What is the ratio of the Oil Rent (as % of GDP) in Bolivia in 1997 to that in 1998?
Your response must be concise. 1.62. What is the ratio of the Oil Rent (as % of GDP) of Canada in 1997 to that in 1998?
Ensure brevity in your answer.  2.21. What is the ratio of the Oil Rent (as % of GDP) in Ukraine in 1997 to that in 1998?
Your response must be concise. 1.59. What is the difference between the highest and the second highest Oil Rent (as % of GDP) of Australia?
Your answer should be compact. 0.05. What is the difference between the highest and the second highest Oil Rent (as % of GDP) of Bolivia?
Give a very brief answer. 0.53. What is the difference between the highest and the second highest Oil Rent (as % of GDP) of Canada?
Provide a short and direct response. 0.12. What is the difference between the highest and the second highest Oil Rent (as % of GDP) in Ukraine?
Provide a succinct answer. 0.15. What is the difference between the highest and the lowest Oil Rent (as % of GDP) of Australia?
Provide a short and direct response. 0.46. What is the difference between the highest and the lowest Oil Rent (as % of GDP) of Bolivia?
Make the answer very short. 1.4. What is the difference between the highest and the lowest Oil Rent (as % of GDP) of Canada?
Offer a very short reply. 0.83. What is the difference between the highest and the lowest Oil Rent (as % of GDP) of Ukraine?
Ensure brevity in your answer.  0.39. 